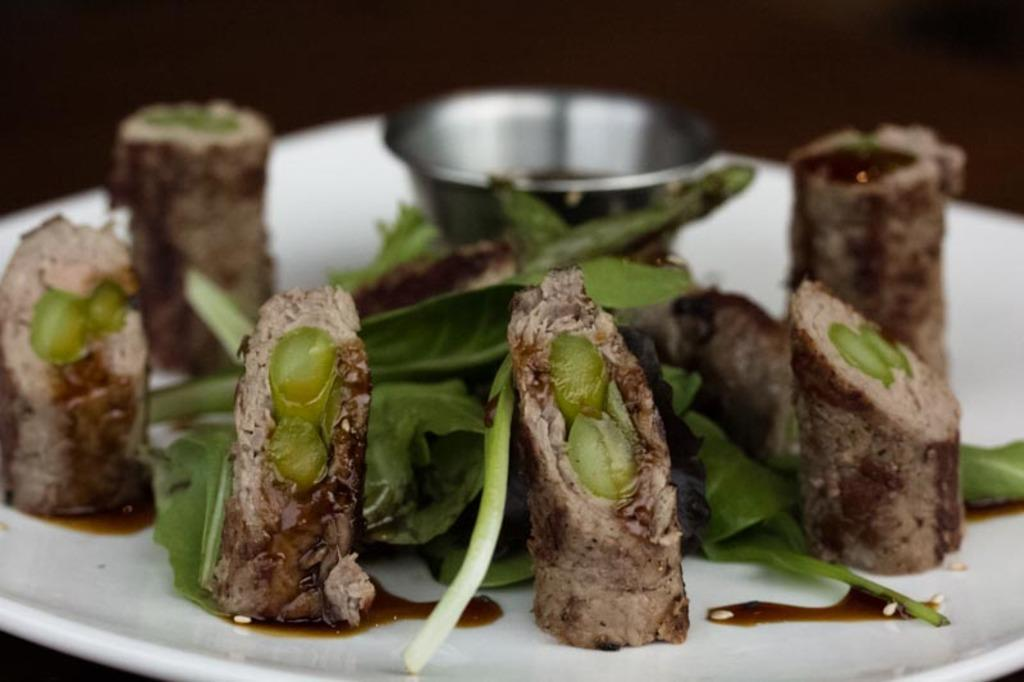What type of objects can be seen in the image? There are food items and a steel bowl in the image. Can you describe the steel bowl? The steel bowl is on a white plate. What can be observed about the background of the image? The background of the image is blurred. How many frogs are sitting on the bells in the image? There are no frogs or bells present in the image. What color is the cub's fur in the image? There is no cub present in the image. 